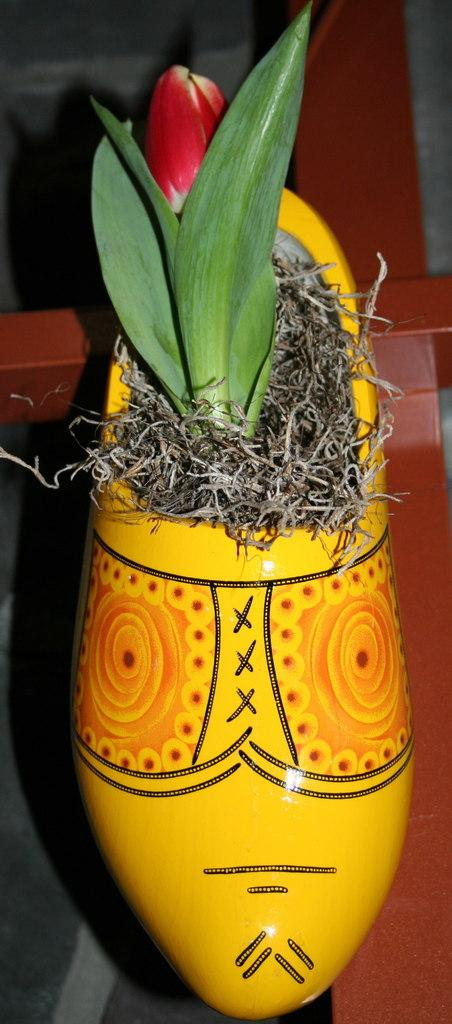What type of plant is in the image? There is a flower plant in the image. What is the flower plant placed in? The flower plant is in a yellow-colored flower vase. Where is the flower vase located? The flower vase is present on a table. How does the flower plant affect the insurance rates in the image? The image does not depict any insurance rates or their relation to the flower plant. 